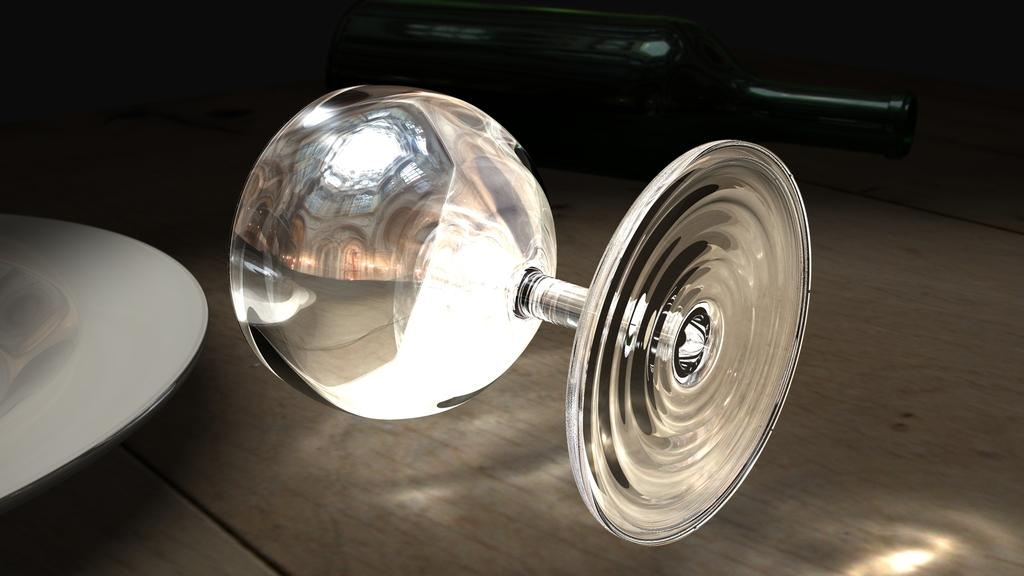What type of container is present in the image? There is a glass in the image. What else can be seen in the background of the image? There is a bottle in the background of the image. How would you describe the lighting in the image? The image appears to be slightly dark. What color is the object visible in the image? There is a white object visible in the image. Who created the breakfast depicted in the image? There is no breakfast depicted in the image, so it is not possible to determine who created it. 